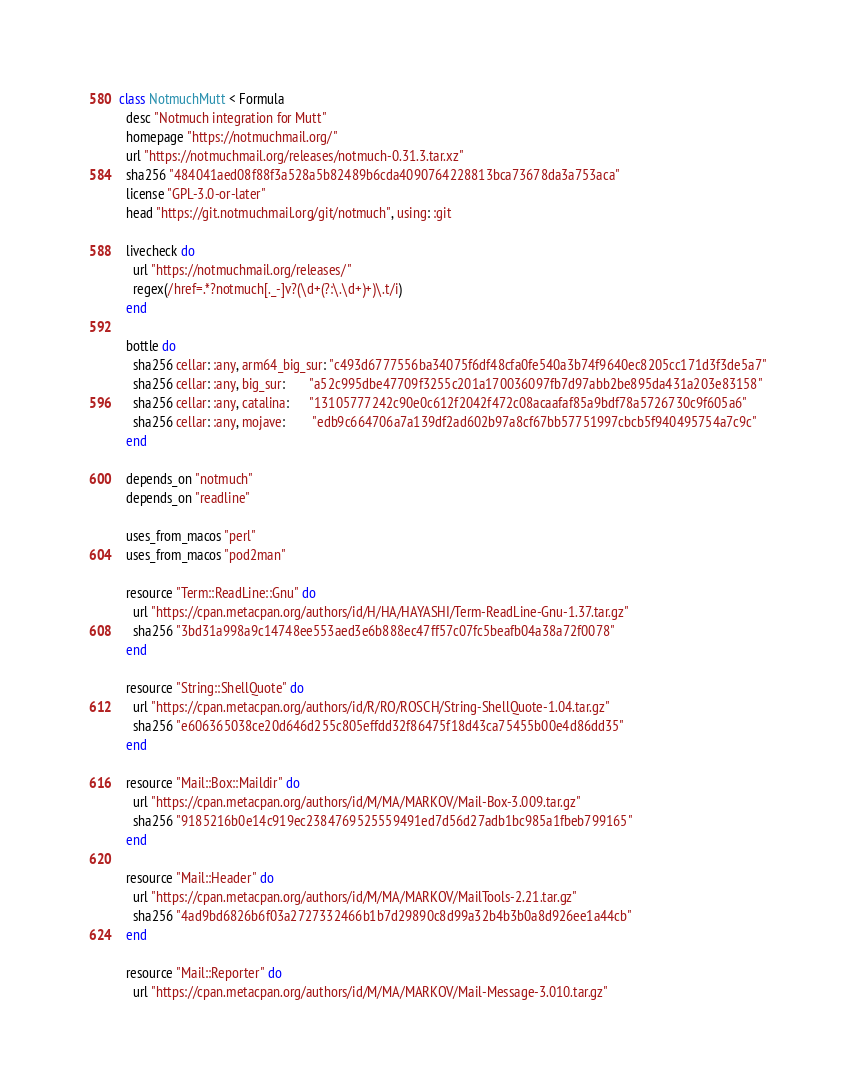<code> <loc_0><loc_0><loc_500><loc_500><_Ruby_>class NotmuchMutt < Formula
  desc "Notmuch integration for Mutt"
  homepage "https://notmuchmail.org/"
  url "https://notmuchmail.org/releases/notmuch-0.31.3.tar.xz"
  sha256 "484041aed08f88f3a528a5b82489b6cda4090764228813bca73678da3a753aca"
  license "GPL-3.0-or-later"
  head "https://git.notmuchmail.org/git/notmuch", using: :git

  livecheck do
    url "https://notmuchmail.org/releases/"
    regex(/href=.*?notmuch[._-]v?(\d+(?:\.\d+)+)\.t/i)
  end

  bottle do
    sha256 cellar: :any, arm64_big_sur: "c493d6777556ba34075f6df48cfa0fe540a3b74f9640ec8205cc171d3f3de5a7"
    sha256 cellar: :any, big_sur:       "a52c995dbe47709f3255c201a170036097fb7d97abb2be895da431a203e83158"
    sha256 cellar: :any, catalina:      "13105777242c90e0c612f2042f472c08acaafaf85a9bdf78a5726730c9f605a6"
    sha256 cellar: :any, mojave:        "edb9c664706a7a139df2ad602b97a8cf67bb57751997cbcb5f940495754a7c9c"
  end

  depends_on "notmuch"
  depends_on "readline"

  uses_from_macos "perl"
  uses_from_macos "pod2man"

  resource "Term::ReadLine::Gnu" do
    url "https://cpan.metacpan.org/authors/id/H/HA/HAYASHI/Term-ReadLine-Gnu-1.37.tar.gz"
    sha256 "3bd31a998a9c14748ee553aed3e6b888ec47ff57c07fc5beafb04a38a72f0078"
  end

  resource "String::ShellQuote" do
    url "https://cpan.metacpan.org/authors/id/R/RO/ROSCH/String-ShellQuote-1.04.tar.gz"
    sha256 "e606365038ce20d646d255c805effdd32f86475f18d43ca75455b00e4d86dd35"
  end

  resource "Mail::Box::Maildir" do
    url "https://cpan.metacpan.org/authors/id/M/MA/MARKOV/Mail-Box-3.009.tar.gz"
    sha256 "9185216b0e14c919ec2384769525559491ed7d56d27adb1bc985a1fbeb799165"
  end

  resource "Mail::Header" do
    url "https://cpan.metacpan.org/authors/id/M/MA/MARKOV/MailTools-2.21.tar.gz"
    sha256 "4ad9bd6826b6f03a2727332466b1b7d29890c8d99a32b4b3b0a8d926ee1a44cb"
  end

  resource "Mail::Reporter" do
    url "https://cpan.metacpan.org/authors/id/M/MA/MARKOV/Mail-Message-3.010.tar.gz"</code> 